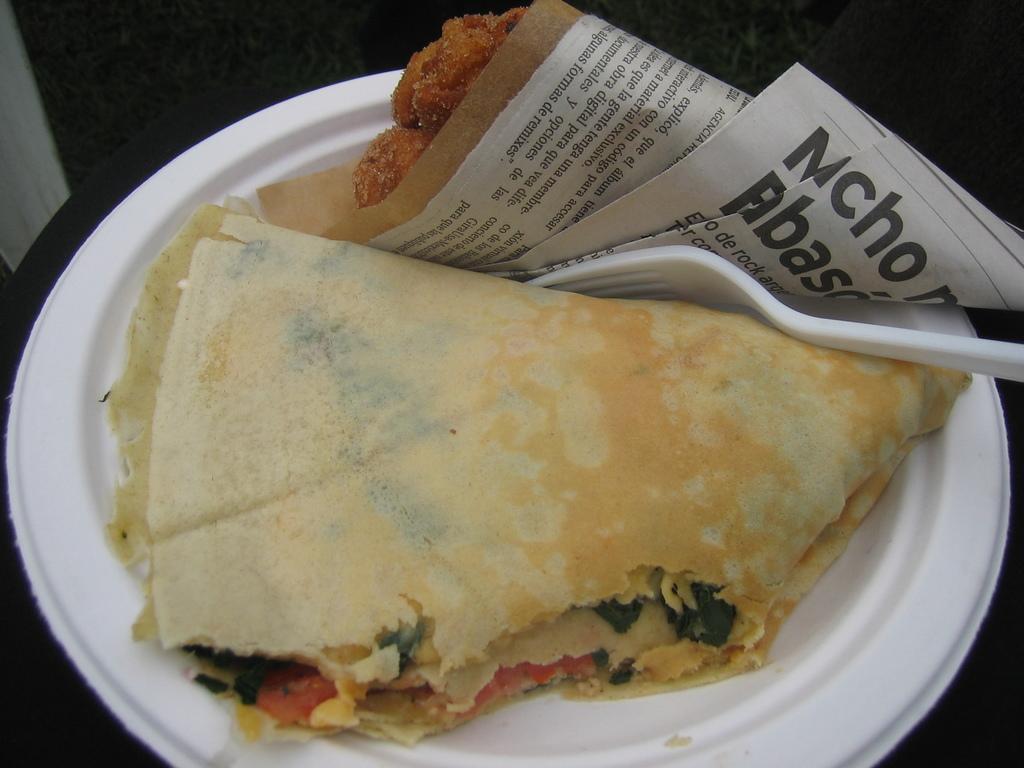In one or two sentences, can you explain what this image depicts? In this picture we can see food items, papers, fork on a white plate and in the background it is dark. 